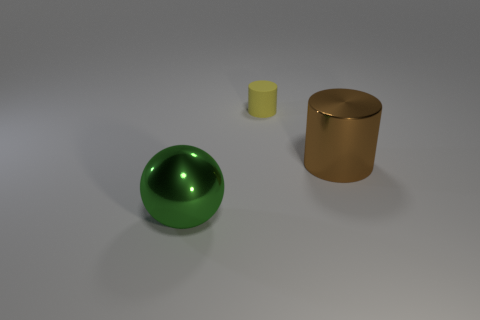Add 2 brown cubes. How many objects exist? 5 Subtract all cylinders. How many objects are left? 1 Subtract all small yellow things. Subtract all large things. How many objects are left? 0 Add 2 yellow cylinders. How many yellow cylinders are left? 3 Add 2 small yellow matte things. How many small yellow matte things exist? 3 Subtract 0 purple spheres. How many objects are left? 3 